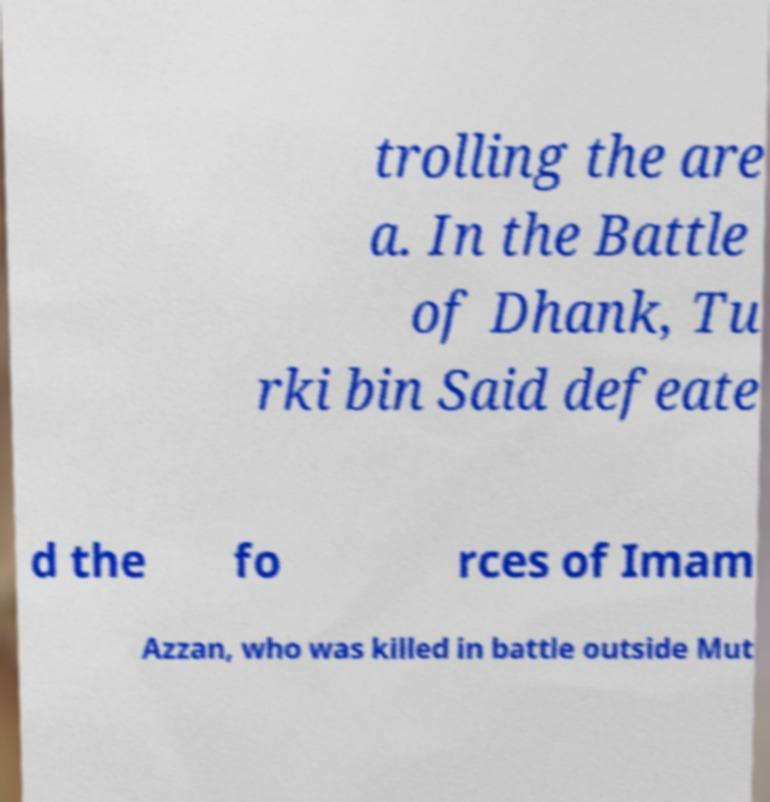I need the written content from this picture converted into text. Can you do that? trolling the are a. In the Battle of Dhank, Tu rki bin Said defeate d the fo rces of Imam Azzan, who was killed in battle outside Mut 